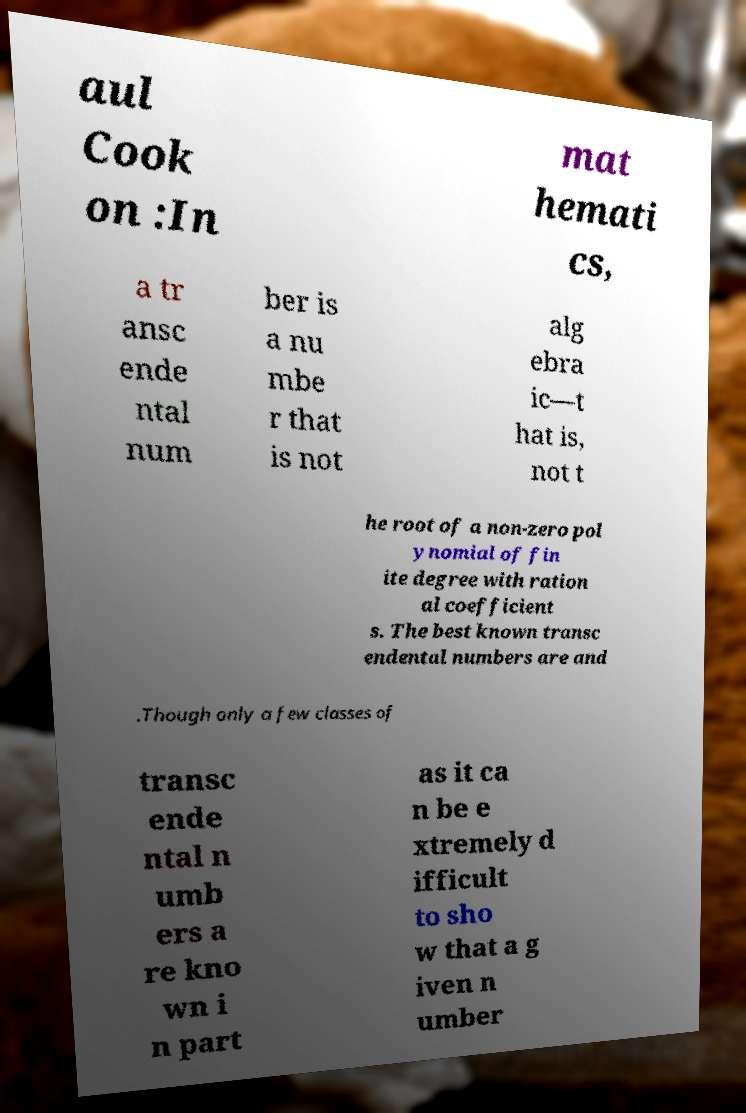Can you read and provide the text displayed in the image?This photo seems to have some interesting text. Can you extract and type it out for me? aul Cook on :In mat hemati cs, a tr ansc ende ntal num ber is a nu mbe r that is not alg ebra ic—t hat is, not t he root of a non-zero pol ynomial of fin ite degree with ration al coefficient s. The best known transc endental numbers are and .Though only a few classes of transc ende ntal n umb ers a re kno wn i n part as it ca n be e xtremely d ifficult to sho w that a g iven n umber 